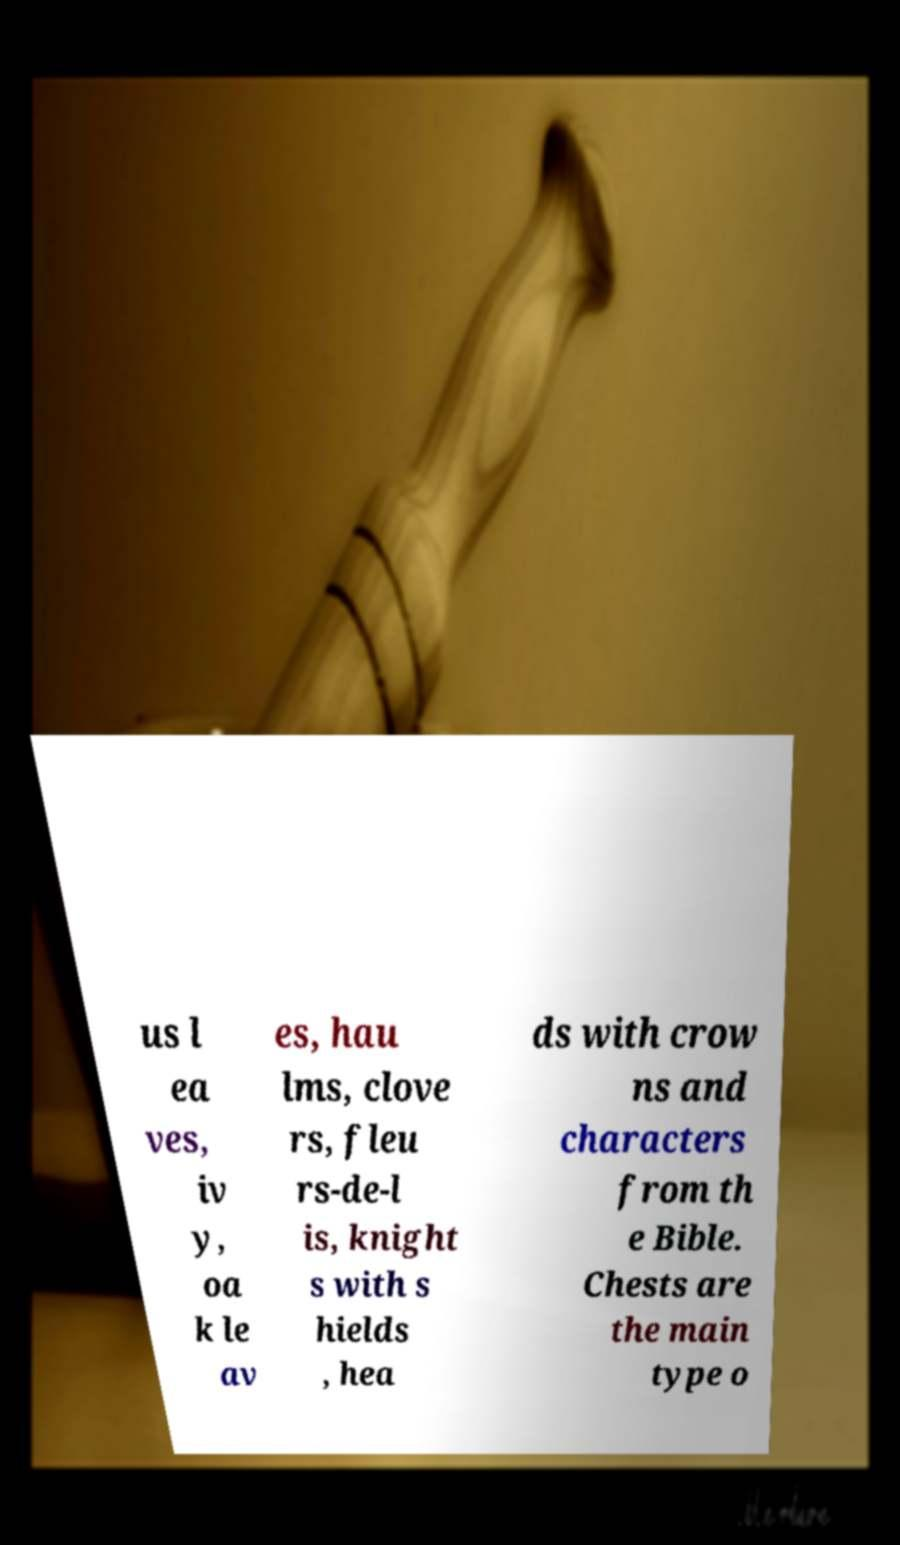Could you assist in decoding the text presented in this image and type it out clearly? us l ea ves, iv y, oa k le av es, hau lms, clove rs, fleu rs-de-l is, knight s with s hields , hea ds with crow ns and characters from th e Bible. Chests are the main type o 